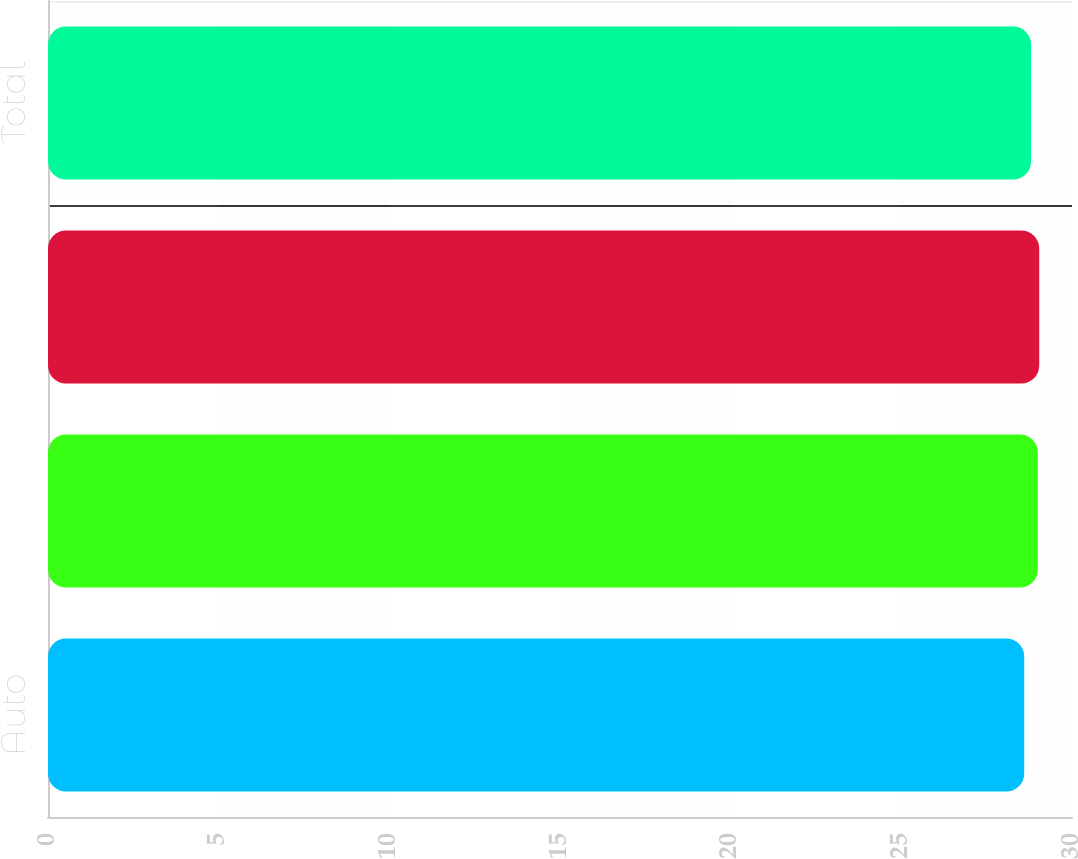<chart> <loc_0><loc_0><loc_500><loc_500><bar_chart><fcel>Auto<fcel>Homeowners<fcel>Other personal lines<fcel>Total<nl><fcel>28.6<fcel>29<fcel>29.04<fcel>28.8<nl></chart> 